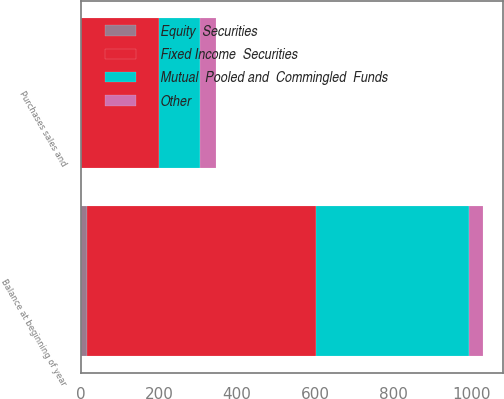Convert chart to OTSL. <chart><loc_0><loc_0><loc_500><loc_500><stacked_bar_chart><ecel><fcel>Purchases sales and<fcel>Balance at beginning of year<nl><fcel>Other<fcel>41<fcel>36<nl><fcel>Fixed Income  Securities<fcel>198<fcel>584<nl><fcel>Mutual  Pooled and  Commingled  Funds<fcel>106<fcel>392<nl><fcel>Equity  Securities<fcel>1<fcel>17<nl></chart> 